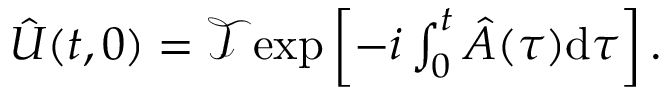Convert formula to latex. <formula><loc_0><loc_0><loc_500><loc_500>\begin{array} { r } { \hat { U } ( t , 0 ) = \mathcal { T } e x p \left [ - i \int _ { 0 } ^ { t } \hat { A } ( \tau ) d \tau \right ] . } \end{array}</formula> 